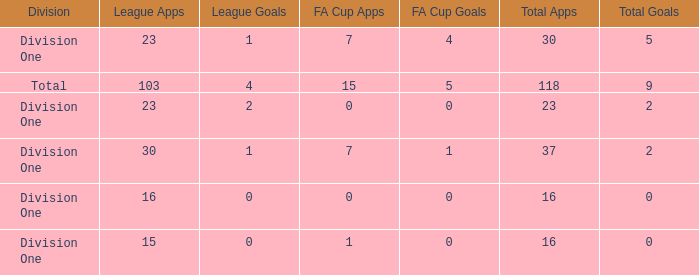It has a FA Cup Goals smaller than 4, and a FA Cup Apps larger than 7, what is the total number of total apps? 0.0. 